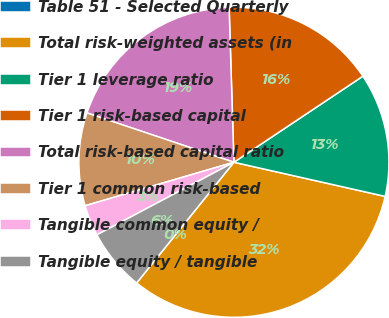Convert chart to OTSL. <chart><loc_0><loc_0><loc_500><loc_500><pie_chart><fcel>Table 51 - Selected Quarterly<fcel>Total risk-weighted assets (in<fcel>Tier 1 leverage ratio<fcel>Tier 1 risk-based capital<fcel>Total risk-based capital ratio<fcel>Tier 1 common risk-based<fcel>Tangible common equity /<fcel>Tangible equity / tangible<nl><fcel>0.0%<fcel>32.26%<fcel>12.9%<fcel>16.13%<fcel>19.35%<fcel>9.68%<fcel>3.23%<fcel>6.45%<nl></chart> 